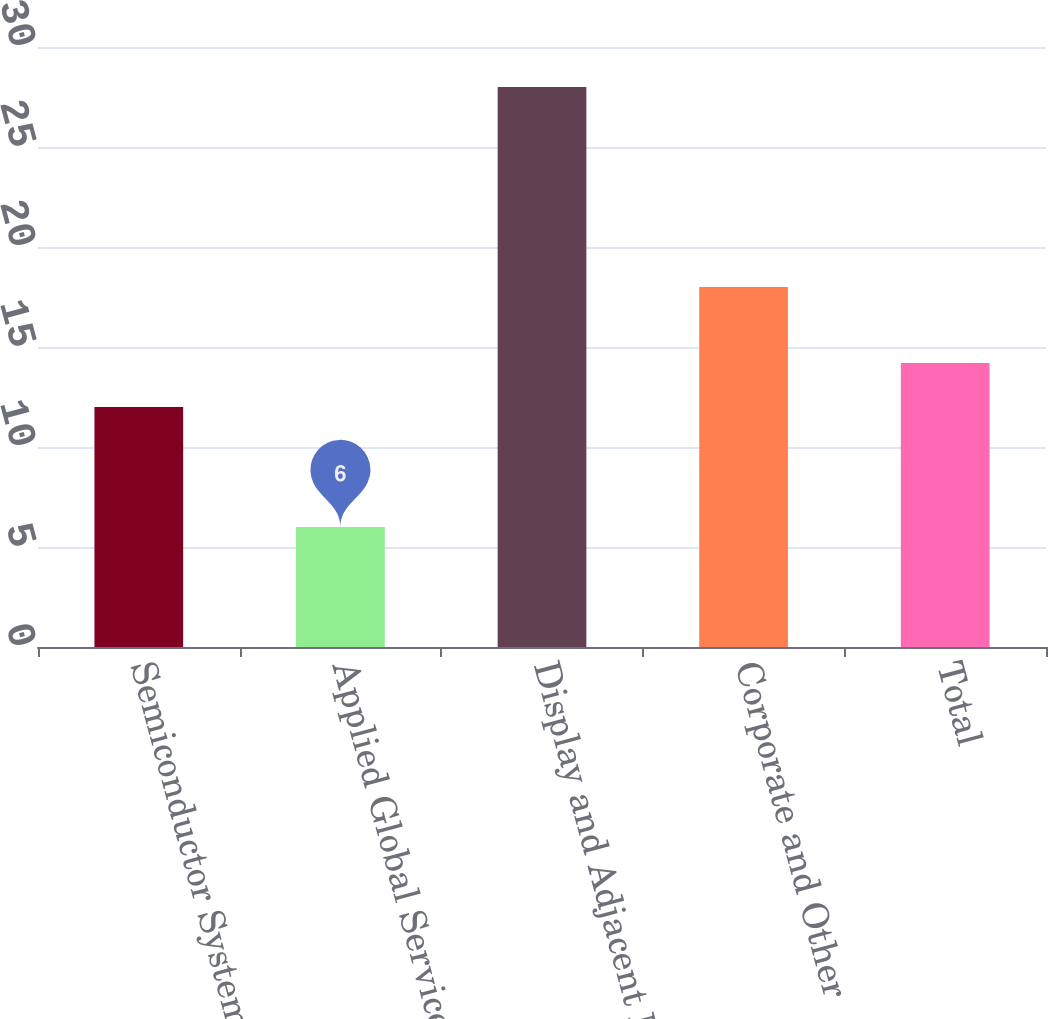Convert chart to OTSL. <chart><loc_0><loc_0><loc_500><loc_500><bar_chart><fcel>Semiconductor Systems<fcel>Applied Global Services<fcel>Display and Adjacent Markets<fcel>Corporate and Other<fcel>Total<nl><fcel>12<fcel>6<fcel>28<fcel>18<fcel>14.2<nl></chart> 